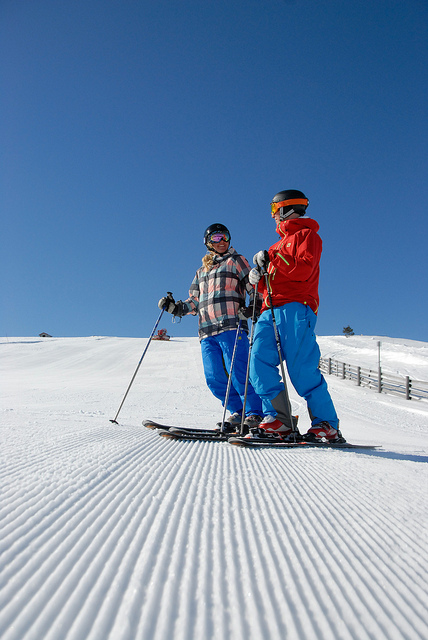Describe the weather conditions at the ski resort. The weather conditions appear to be ideal for skiing, with clear blue skies and no visible signs of inclement weather, which indicates a good visibility for skiing.  What safety gear should one wear when skiing? For safety, skiers should wear helmets, goggles for eye protection, and gloves or mittens. Protective padding and proper layered clothing is also recommended. 